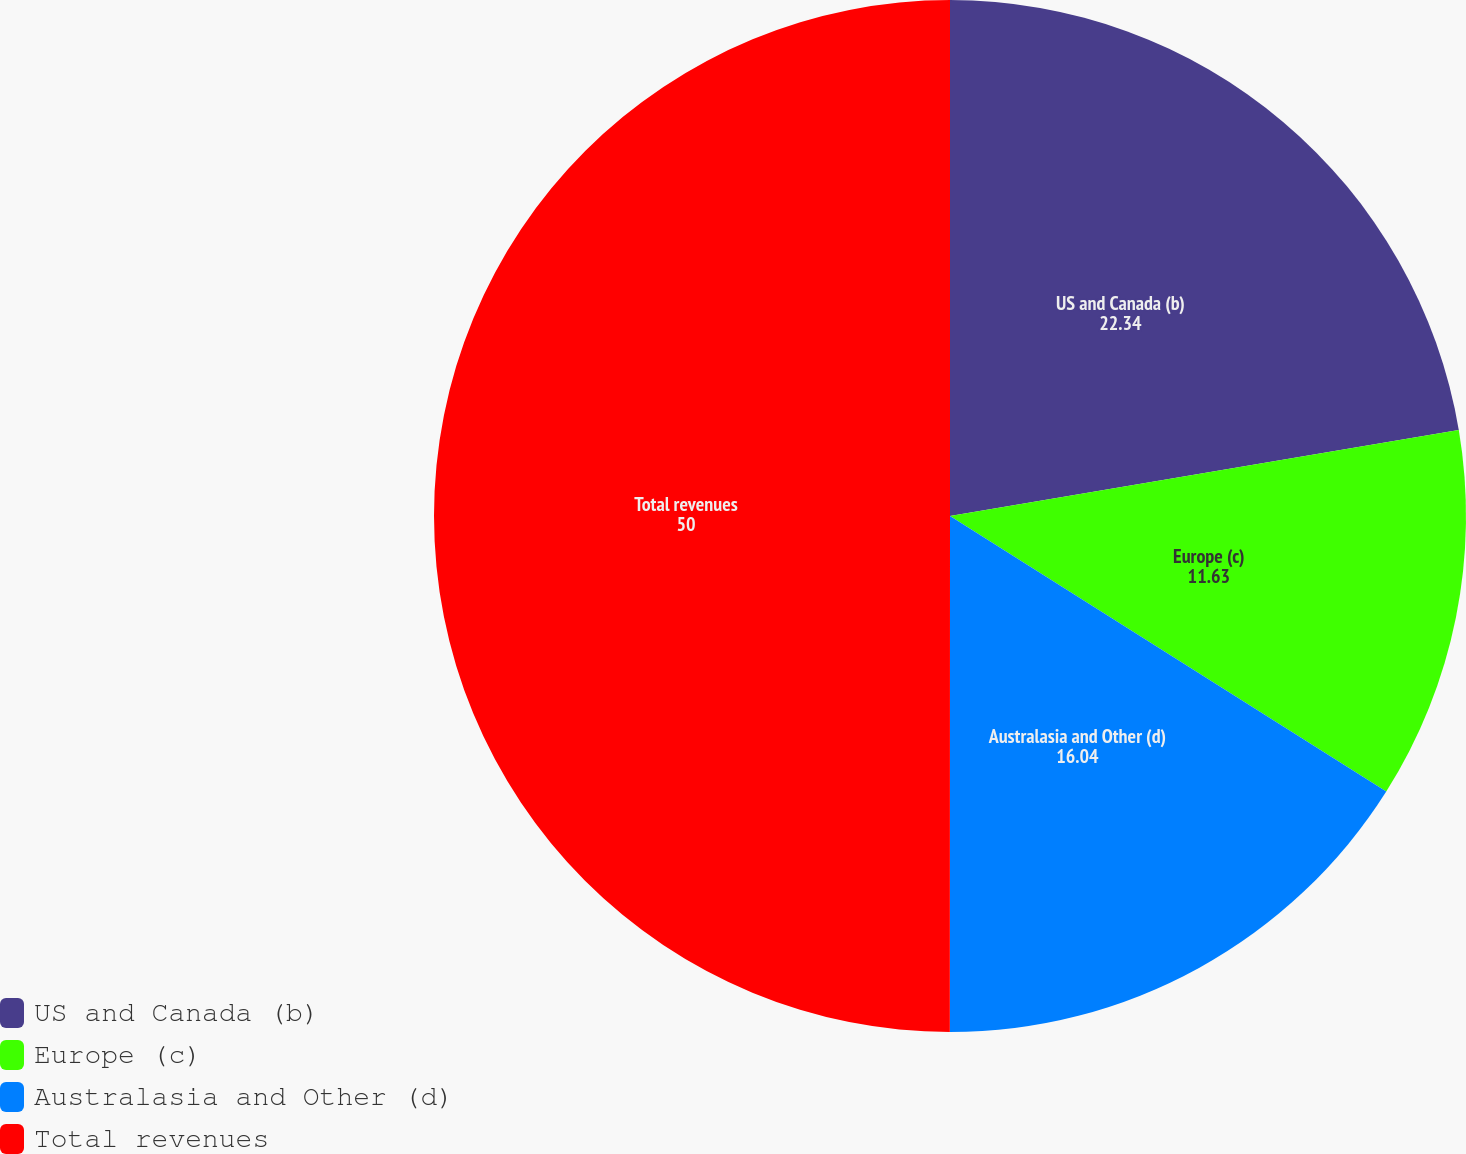Convert chart to OTSL. <chart><loc_0><loc_0><loc_500><loc_500><pie_chart><fcel>US and Canada (b)<fcel>Europe (c)<fcel>Australasia and Other (d)<fcel>Total revenues<nl><fcel>22.34%<fcel>11.63%<fcel>16.04%<fcel>50.0%<nl></chart> 